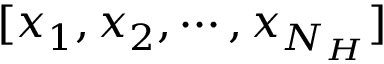Convert formula to latex. <formula><loc_0><loc_0><loc_500><loc_500>[ x _ { 1 } , x _ { 2 } , \cdots , x _ { N _ { H } } ]</formula> 